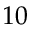<formula> <loc_0><loc_0><loc_500><loc_500>1 0</formula> 